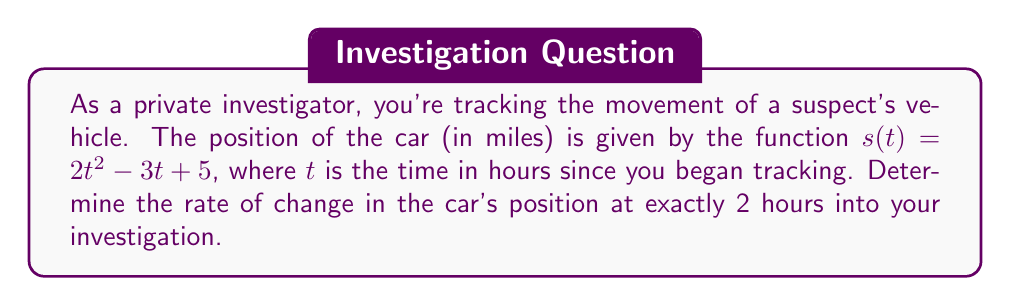What is the answer to this math problem? To find the rate of change at a specific point in time, we need to calculate the derivative of the position function and evaluate it at the given time.

1) The position function is $s(t) = 2t^2 - 3t + 5$

2) To find the rate of change function (velocity), we take the derivative:
   $$\frac{d}{dt}s(t) = \frac{d}{dt}(2t^2 - 3t + 5)$$
   $$s'(t) = 4t - 3$$

3) This function $s'(t)$ represents the instantaneous rate of change of position, or velocity, at any time $t$.

4) We want to find the rate of change at $t = 2$ hours:
   $$s'(2) = 4(2) - 3 = 8 - 3 = 5$$

5) The units for this rate of change would be miles per hour, as we're measuring change in position (miles) over time (hours).

Therefore, at exactly 2 hours into the investigation, the car's velocity (rate of change of position) is 5 miles per hour.
Answer: 5 miles per hour 